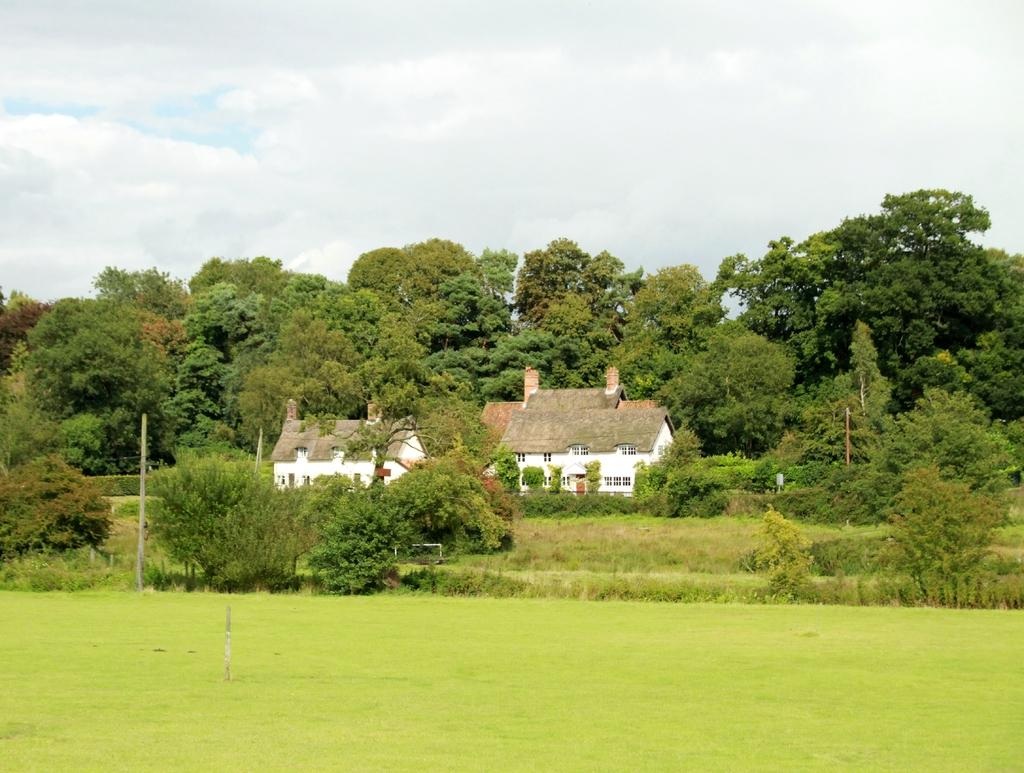What type of vegetation can be seen in the image? There is grass in the image. What other natural elements are present in the image? There are trees in the image. What man-made structures can be seen in the image? There are poles and houses in the image. How would you describe the sky in the image? The sky is cloudy in the image. Can you see any flesh in the image? There is no flesh present in the image; it features natural elements like grass and trees, as well as man-made structures like poles and houses. Is the grandfather mentioned or depicted in the image? There is no mention or depiction of a grandfather in the image. 